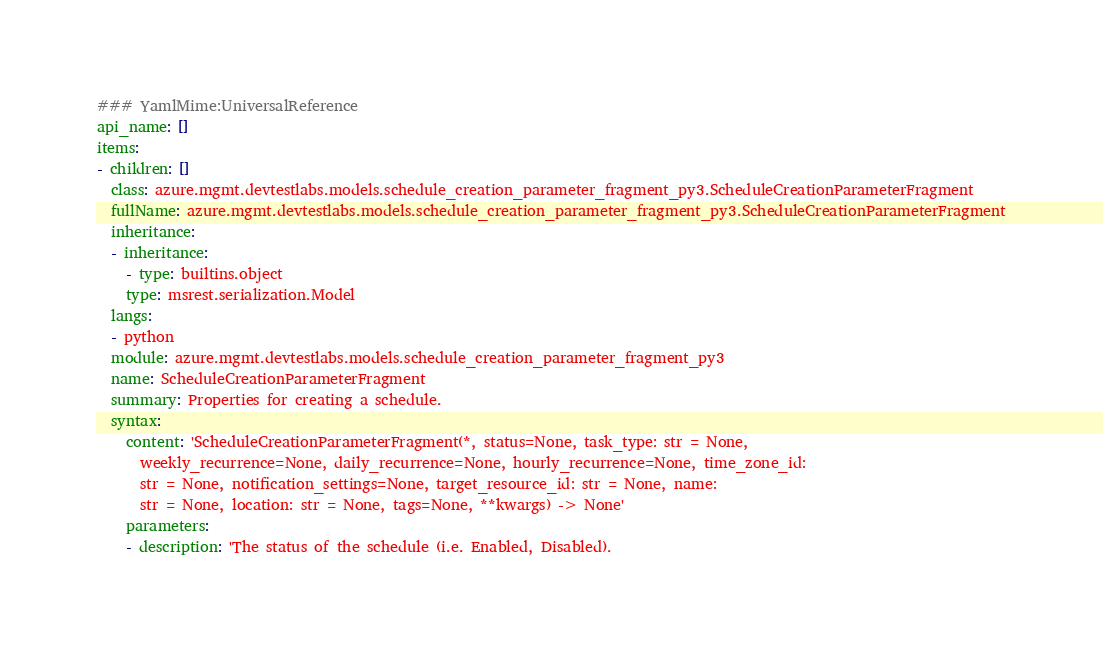<code> <loc_0><loc_0><loc_500><loc_500><_YAML_>### YamlMime:UniversalReference
api_name: []
items:
- children: []
  class: azure.mgmt.devtestlabs.models.schedule_creation_parameter_fragment_py3.ScheduleCreationParameterFragment
  fullName: azure.mgmt.devtestlabs.models.schedule_creation_parameter_fragment_py3.ScheduleCreationParameterFragment
  inheritance:
  - inheritance:
    - type: builtins.object
    type: msrest.serialization.Model
  langs:
  - python
  module: azure.mgmt.devtestlabs.models.schedule_creation_parameter_fragment_py3
  name: ScheduleCreationParameterFragment
  summary: Properties for creating a schedule.
  syntax:
    content: 'ScheduleCreationParameterFragment(*, status=None, task_type: str = None,
      weekly_recurrence=None, daily_recurrence=None, hourly_recurrence=None, time_zone_id:
      str = None, notification_settings=None, target_resource_id: str = None, name:
      str = None, location: str = None, tags=None, **kwargs) -> None'
    parameters:
    - description: 'The status of the schedule (i.e. Enabled, Disabled).
</code> 